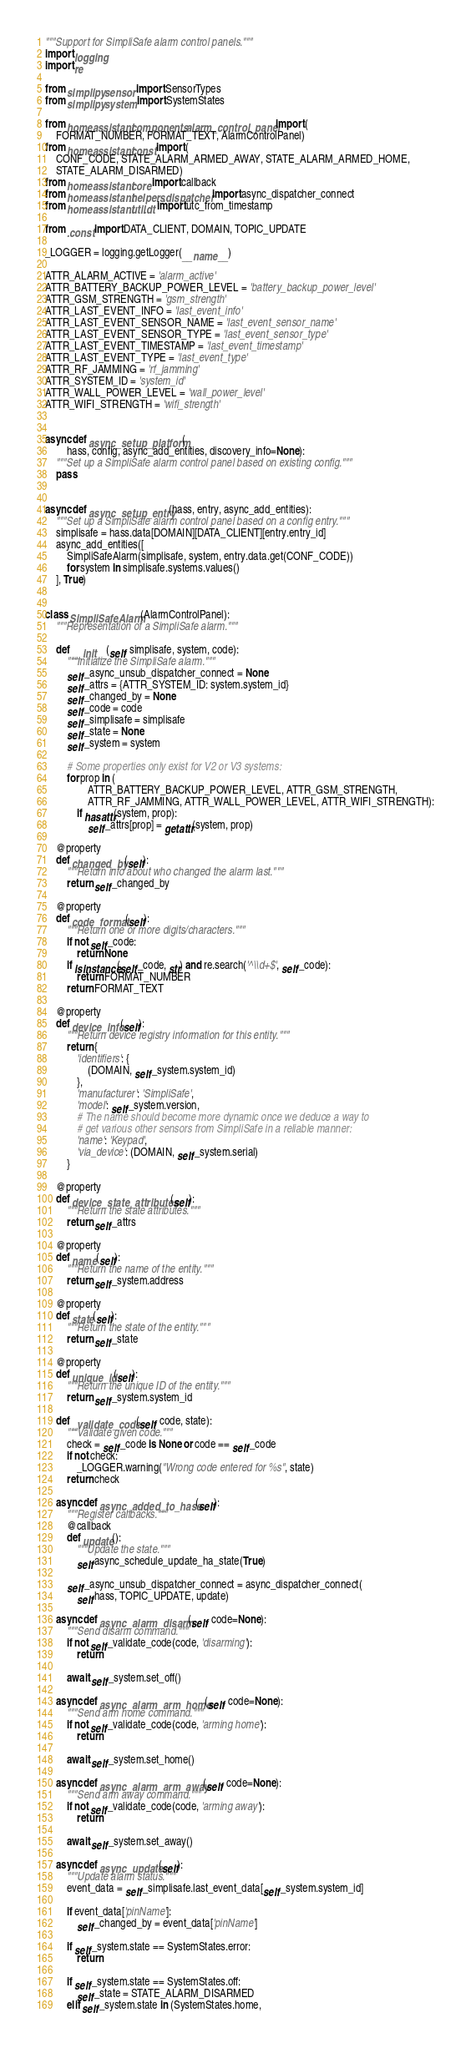Convert code to text. <code><loc_0><loc_0><loc_500><loc_500><_Python_>
"""Support for SimpliSafe alarm control panels."""
import logging
import re

from simplipy.sensor import SensorTypes
from simplipy.system import SystemStates

from homeassistant.components.alarm_control_panel import (
    FORMAT_NUMBER, FORMAT_TEXT, AlarmControlPanel)
from homeassistant.const import (
    CONF_CODE, STATE_ALARM_ARMED_AWAY, STATE_ALARM_ARMED_HOME,
    STATE_ALARM_DISARMED)
from homeassistant.core import callback
from homeassistant.helpers.dispatcher import async_dispatcher_connect
from homeassistant.util.dt import utc_from_timestamp

from .const import DATA_CLIENT, DOMAIN, TOPIC_UPDATE

_LOGGER = logging.getLogger(__name__)

ATTR_ALARM_ACTIVE = 'alarm_active'
ATTR_BATTERY_BACKUP_POWER_LEVEL = 'battery_backup_power_level'
ATTR_GSM_STRENGTH = 'gsm_strength'
ATTR_LAST_EVENT_INFO = 'last_event_info'
ATTR_LAST_EVENT_SENSOR_NAME = 'last_event_sensor_name'
ATTR_LAST_EVENT_SENSOR_TYPE = 'last_event_sensor_type'
ATTR_LAST_EVENT_TIMESTAMP = 'last_event_timestamp'
ATTR_LAST_EVENT_TYPE = 'last_event_type'
ATTR_RF_JAMMING = 'rf_jamming'
ATTR_SYSTEM_ID = 'system_id'
ATTR_WALL_POWER_LEVEL = 'wall_power_level'
ATTR_WIFI_STRENGTH = 'wifi_strength'


async def async_setup_platform(
        hass, config, async_add_entities, discovery_info=None):
    """Set up a SimpliSafe alarm control panel based on existing config."""
    pass


async def async_setup_entry(hass, entry, async_add_entities):
    """Set up a SimpliSafe alarm control panel based on a config entry."""
    simplisafe = hass.data[DOMAIN][DATA_CLIENT][entry.entry_id]
    async_add_entities([
        SimpliSafeAlarm(simplisafe, system, entry.data.get(CONF_CODE))
        for system in simplisafe.systems.values()
    ], True)


class SimpliSafeAlarm(AlarmControlPanel):
    """Representation of a SimpliSafe alarm."""

    def __init__(self, simplisafe, system, code):
        """Initialize the SimpliSafe alarm."""
        self._async_unsub_dispatcher_connect = None
        self._attrs = {ATTR_SYSTEM_ID: system.system_id}
        self._changed_by = None
        self._code = code
        self._simplisafe = simplisafe
        self._state = None
        self._system = system

        # Some properties only exist for V2 or V3 systems:
        for prop in (
                ATTR_BATTERY_BACKUP_POWER_LEVEL, ATTR_GSM_STRENGTH,
                ATTR_RF_JAMMING, ATTR_WALL_POWER_LEVEL, ATTR_WIFI_STRENGTH):
            if hasattr(system, prop):
                self._attrs[prop] = getattr(system, prop)

    @property
    def changed_by(self):
        """Return info about who changed the alarm last."""
        return self._changed_by

    @property
    def code_format(self):
        """Return one or more digits/characters."""
        if not self._code:
            return None
        if isinstance(self._code, str) and re.search('^\\d+$', self._code):
            return FORMAT_NUMBER
        return FORMAT_TEXT

    @property
    def device_info(self):
        """Return device registry information for this entity."""
        return {
            'identifiers': {
                (DOMAIN, self._system.system_id)
            },
            'manufacturer': 'SimpliSafe',
            'model': self._system.version,
            # The name should become more dynamic once we deduce a way to
            # get various other sensors from SimpliSafe in a reliable manner:
            'name': 'Keypad',
            'via_device': (DOMAIN, self._system.serial)
        }

    @property
    def device_state_attributes(self):
        """Return the state attributes."""
        return self._attrs

    @property
    def name(self):
        """Return the name of the entity."""
        return self._system.address

    @property
    def state(self):
        """Return the state of the entity."""
        return self._state

    @property
    def unique_id(self):
        """Return the unique ID of the entity."""
        return self._system.system_id

    def _validate_code(self, code, state):
        """Validate given code."""
        check = self._code is None or code == self._code
        if not check:
            _LOGGER.warning("Wrong code entered for %s", state)
        return check

    async def async_added_to_hass(self):
        """Register callbacks."""
        @callback
        def update():
            """Update the state."""
            self.async_schedule_update_ha_state(True)

        self._async_unsub_dispatcher_connect = async_dispatcher_connect(
            self.hass, TOPIC_UPDATE, update)

    async def async_alarm_disarm(self, code=None):
        """Send disarm command."""
        if not self._validate_code(code, 'disarming'):
            return

        await self._system.set_off()

    async def async_alarm_arm_home(self, code=None):
        """Send arm home command."""
        if not self._validate_code(code, 'arming home'):
            return

        await self._system.set_home()

    async def async_alarm_arm_away(self, code=None):
        """Send arm away command."""
        if not self._validate_code(code, 'arming away'):
            return

        await self._system.set_away()

    async def async_update(self):
        """Update alarm status."""
        event_data = self._simplisafe.last_event_data[self._system.system_id]

        if event_data['pinName']:
            self._changed_by = event_data['pinName']

        if self._system.state == SystemStates.error:
            return

        if self._system.state == SystemStates.off:
            self._state = STATE_ALARM_DISARMED
        elif self._system.state in (SystemStates.home,</code> 